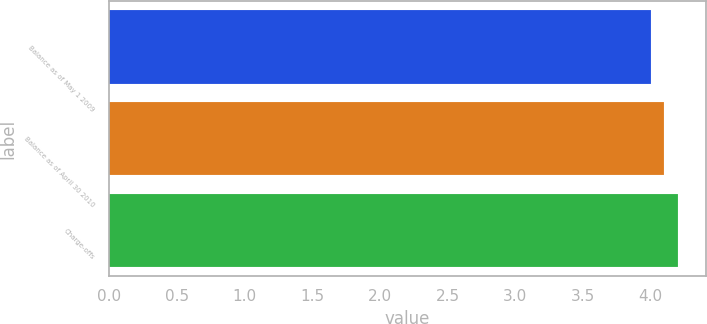<chart> <loc_0><loc_0><loc_500><loc_500><bar_chart><fcel>Balance as of May 1 2009<fcel>Balance as of April 30 2010<fcel>Charge-offs<nl><fcel>4<fcel>4.1<fcel>4.2<nl></chart> 